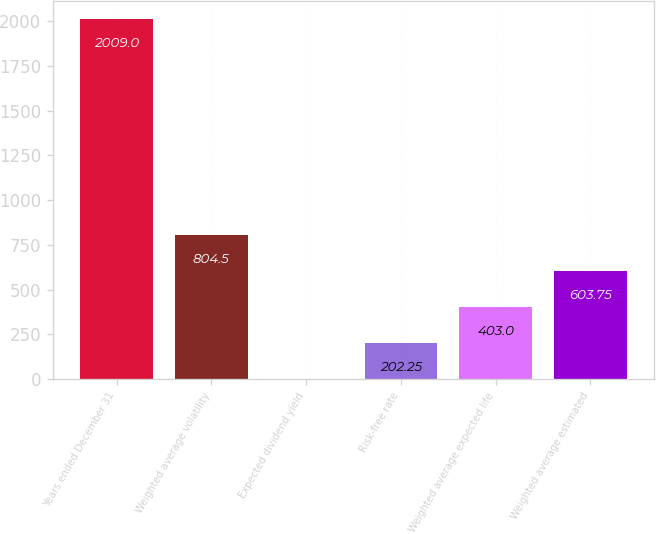<chart> <loc_0><loc_0><loc_500><loc_500><bar_chart><fcel>Years ended December 31<fcel>Weighted average volatility<fcel>Expected dividend yield<fcel>Risk-free rate<fcel>Weighted average expected life<fcel>Weighted average estimated<nl><fcel>2009<fcel>804.5<fcel>1.5<fcel>202.25<fcel>403<fcel>603.75<nl></chart> 